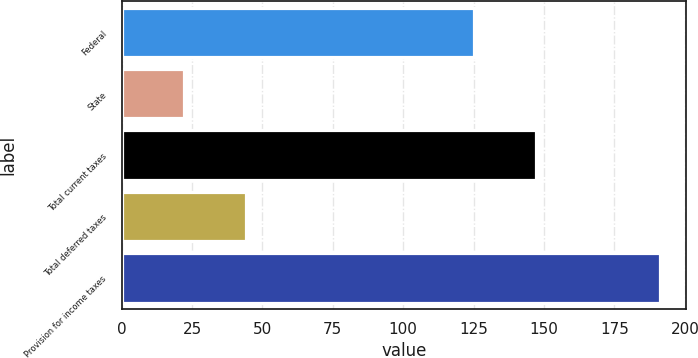Convert chart. <chart><loc_0><loc_0><loc_500><loc_500><bar_chart><fcel>Federal<fcel>State<fcel>Total current taxes<fcel>Total deferred taxes<fcel>Provision for income taxes<nl><fcel>125<fcel>22<fcel>147<fcel>44<fcel>191<nl></chart> 